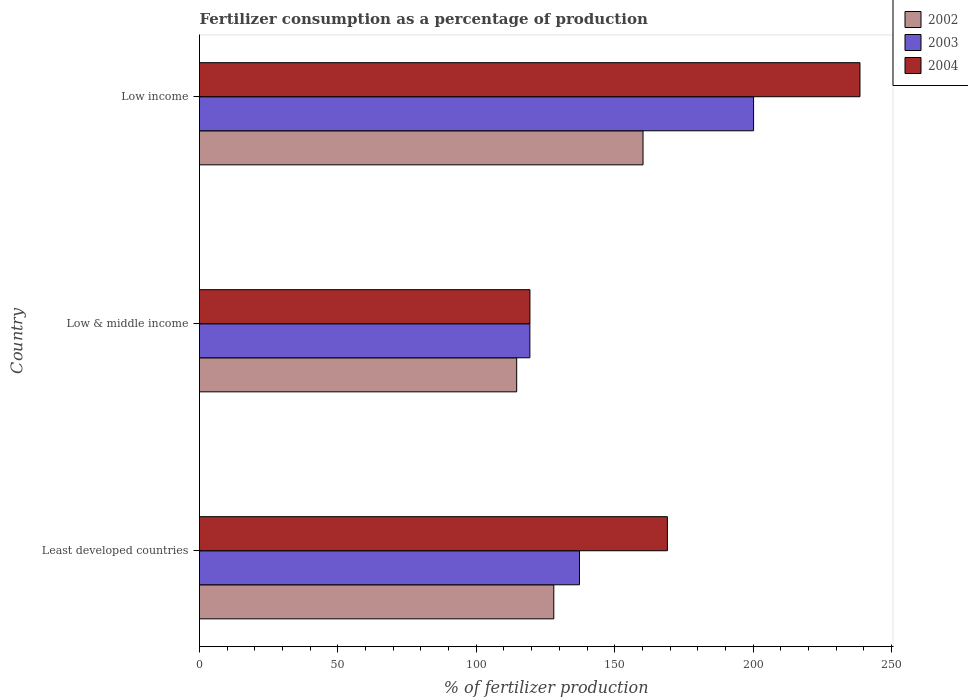How many different coloured bars are there?
Provide a short and direct response. 3. How many bars are there on the 3rd tick from the bottom?
Provide a succinct answer. 3. What is the label of the 1st group of bars from the top?
Your answer should be very brief. Low income. In how many cases, is the number of bars for a given country not equal to the number of legend labels?
Ensure brevity in your answer.  0. What is the percentage of fertilizers consumed in 2003 in Low & middle income?
Make the answer very short. 119.36. Across all countries, what is the maximum percentage of fertilizers consumed in 2004?
Offer a very short reply. 238.61. Across all countries, what is the minimum percentage of fertilizers consumed in 2004?
Ensure brevity in your answer.  119.38. What is the total percentage of fertilizers consumed in 2002 in the graph?
Provide a succinct answer. 402.83. What is the difference between the percentage of fertilizers consumed in 2003 in Low & middle income and that in Low income?
Your answer should be compact. -80.82. What is the difference between the percentage of fertilizers consumed in 2002 in Low income and the percentage of fertilizers consumed in 2004 in Least developed countries?
Provide a succinct answer. -8.8. What is the average percentage of fertilizers consumed in 2004 per country?
Ensure brevity in your answer.  175.68. What is the difference between the percentage of fertilizers consumed in 2003 and percentage of fertilizers consumed in 2002 in Least developed countries?
Give a very brief answer. 9.28. In how many countries, is the percentage of fertilizers consumed in 2004 greater than 20 %?
Make the answer very short. 3. What is the ratio of the percentage of fertilizers consumed in 2003 in Least developed countries to that in Low & middle income?
Keep it short and to the point. 1.15. Is the percentage of fertilizers consumed in 2004 in Least developed countries less than that in Low & middle income?
Give a very brief answer. No. What is the difference between the highest and the second highest percentage of fertilizers consumed in 2002?
Make the answer very short. 32.24. What is the difference between the highest and the lowest percentage of fertilizers consumed in 2003?
Give a very brief answer. 80.82. In how many countries, is the percentage of fertilizers consumed in 2004 greater than the average percentage of fertilizers consumed in 2004 taken over all countries?
Offer a very short reply. 1. What does the 3rd bar from the top in Low income represents?
Your answer should be very brief. 2002. What does the 2nd bar from the bottom in Least developed countries represents?
Your response must be concise. 2003. Are all the bars in the graph horizontal?
Provide a short and direct response. Yes. What is the difference between two consecutive major ticks on the X-axis?
Make the answer very short. 50. Are the values on the major ticks of X-axis written in scientific E-notation?
Provide a succinct answer. No. Does the graph contain any zero values?
Provide a succinct answer. No. Does the graph contain grids?
Keep it short and to the point. No. What is the title of the graph?
Provide a short and direct response. Fertilizer consumption as a percentage of production. Does "2010" appear as one of the legend labels in the graph?
Offer a very short reply. No. What is the label or title of the X-axis?
Make the answer very short. % of fertilizer production. What is the label or title of the Y-axis?
Your answer should be compact. Country. What is the % of fertilizer production of 2002 in Least developed countries?
Your answer should be very brief. 128. What is the % of fertilizer production of 2003 in Least developed countries?
Provide a succinct answer. 137.28. What is the % of fertilizer production of 2004 in Least developed countries?
Keep it short and to the point. 169.04. What is the % of fertilizer production of 2002 in Low & middle income?
Offer a terse response. 114.59. What is the % of fertilizer production of 2003 in Low & middle income?
Your response must be concise. 119.36. What is the % of fertilizer production in 2004 in Low & middle income?
Keep it short and to the point. 119.38. What is the % of fertilizer production in 2002 in Low income?
Ensure brevity in your answer.  160.24. What is the % of fertilizer production of 2003 in Low income?
Your answer should be compact. 200.18. What is the % of fertilizer production of 2004 in Low income?
Your answer should be very brief. 238.61. Across all countries, what is the maximum % of fertilizer production of 2002?
Your answer should be very brief. 160.24. Across all countries, what is the maximum % of fertilizer production in 2003?
Make the answer very short. 200.18. Across all countries, what is the maximum % of fertilizer production in 2004?
Give a very brief answer. 238.61. Across all countries, what is the minimum % of fertilizer production in 2002?
Offer a terse response. 114.59. Across all countries, what is the minimum % of fertilizer production in 2003?
Provide a short and direct response. 119.36. Across all countries, what is the minimum % of fertilizer production of 2004?
Provide a succinct answer. 119.38. What is the total % of fertilizer production in 2002 in the graph?
Keep it short and to the point. 402.83. What is the total % of fertilizer production of 2003 in the graph?
Ensure brevity in your answer.  456.81. What is the total % of fertilizer production in 2004 in the graph?
Your answer should be very brief. 527.03. What is the difference between the % of fertilizer production of 2002 in Least developed countries and that in Low & middle income?
Give a very brief answer. 13.4. What is the difference between the % of fertilizer production in 2003 in Least developed countries and that in Low & middle income?
Offer a terse response. 17.92. What is the difference between the % of fertilizer production in 2004 in Least developed countries and that in Low & middle income?
Your answer should be very brief. 49.66. What is the difference between the % of fertilizer production of 2002 in Least developed countries and that in Low income?
Your response must be concise. -32.24. What is the difference between the % of fertilizer production of 2003 in Least developed countries and that in Low income?
Keep it short and to the point. -62.9. What is the difference between the % of fertilizer production of 2004 in Least developed countries and that in Low income?
Provide a short and direct response. -69.57. What is the difference between the % of fertilizer production in 2002 in Low & middle income and that in Low income?
Offer a very short reply. -45.65. What is the difference between the % of fertilizer production in 2003 in Low & middle income and that in Low income?
Your answer should be compact. -80.82. What is the difference between the % of fertilizer production of 2004 in Low & middle income and that in Low income?
Keep it short and to the point. -119.23. What is the difference between the % of fertilizer production of 2002 in Least developed countries and the % of fertilizer production of 2003 in Low & middle income?
Offer a very short reply. 8.64. What is the difference between the % of fertilizer production of 2002 in Least developed countries and the % of fertilizer production of 2004 in Low & middle income?
Offer a very short reply. 8.62. What is the difference between the % of fertilizer production in 2003 in Least developed countries and the % of fertilizer production in 2004 in Low & middle income?
Ensure brevity in your answer.  17.9. What is the difference between the % of fertilizer production of 2002 in Least developed countries and the % of fertilizer production of 2003 in Low income?
Your answer should be compact. -72.18. What is the difference between the % of fertilizer production in 2002 in Least developed countries and the % of fertilizer production in 2004 in Low income?
Offer a terse response. -110.61. What is the difference between the % of fertilizer production of 2003 in Least developed countries and the % of fertilizer production of 2004 in Low income?
Provide a succinct answer. -101.33. What is the difference between the % of fertilizer production of 2002 in Low & middle income and the % of fertilizer production of 2003 in Low income?
Provide a short and direct response. -85.58. What is the difference between the % of fertilizer production of 2002 in Low & middle income and the % of fertilizer production of 2004 in Low income?
Provide a short and direct response. -124.02. What is the difference between the % of fertilizer production in 2003 in Low & middle income and the % of fertilizer production in 2004 in Low income?
Make the answer very short. -119.26. What is the average % of fertilizer production in 2002 per country?
Make the answer very short. 134.28. What is the average % of fertilizer production of 2003 per country?
Give a very brief answer. 152.27. What is the average % of fertilizer production in 2004 per country?
Give a very brief answer. 175.68. What is the difference between the % of fertilizer production in 2002 and % of fertilizer production in 2003 in Least developed countries?
Keep it short and to the point. -9.28. What is the difference between the % of fertilizer production of 2002 and % of fertilizer production of 2004 in Least developed countries?
Give a very brief answer. -41.04. What is the difference between the % of fertilizer production in 2003 and % of fertilizer production in 2004 in Least developed countries?
Your answer should be very brief. -31.76. What is the difference between the % of fertilizer production in 2002 and % of fertilizer production in 2003 in Low & middle income?
Your response must be concise. -4.76. What is the difference between the % of fertilizer production in 2002 and % of fertilizer production in 2004 in Low & middle income?
Your answer should be very brief. -4.79. What is the difference between the % of fertilizer production of 2003 and % of fertilizer production of 2004 in Low & middle income?
Offer a terse response. -0.02. What is the difference between the % of fertilizer production in 2002 and % of fertilizer production in 2003 in Low income?
Your answer should be compact. -39.94. What is the difference between the % of fertilizer production of 2002 and % of fertilizer production of 2004 in Low income?
Your response must be concise. -78.37. What is the difference between the % of fertilizer production in 2003 and % of fertilizer production in 2004 in Low income?
Your answer should be very brief. -38.43. What is the ratio of the % of fertilizer production of 2002 in Least developed countries to that in Low & middle income?
Give a very brief answer. 1.12. What is the ratio of the % of fertilizer production of 2003 in Least developed countries to that in Low & middle income?
Offer a very short reply. 1.15. What is the ratio of the % of fertilizer production of 2004 in Least developed countries to that in Low & middle income?
Offer a very short reply. 1.42. What is the ratio of the % of fertilizer production of 2002 in Least developed countries to that in Low income?
Provide a short and direct response. 0.8. What is the ratio of the % of fertilizer production in 2003 in Least developed countries to that in Low income?
Your response must be concise. 0.69. What is the ratio of the % of fertilizer production in 2004 in Least developed countries to that in Low income?
Offer a terse response. 0.71. What is the ratio of the % of fertilizer production of 2002 in Low & middle income to that in Low income?
Your answer should be compact. 0.72. What is the ratio of the % of fertilizer production in 2003 in Low & middle income to that in Low income?
Your response must be concise. 0.6. What is the ratio of the % of fertilizer production of 2004 in Low & middle income to that in Low income?
Give a very brief answer. 0.5. What is the difference between the highest and the second highest % of fertilizer production of 2002?
Give a very brief answer. 32.24. What is the difference between the highest and the second highest % of fertilizer production of 2003?
Your answer should be compact. 62.9. What is the difference between the highest and the second highest % of fertilizer production in 2004?
Ensure brevity in your answer.  69.57. What is the difference between the highest and the lowest % of fertilizer production of 2002?
Your answer should be compact. 45.65. What is the difference between the highest and the lowest % of fertilizer production of 2003?
Make the answer very short. 80.82. What is the difference between the highest and the lowest % of fertilizer production in 2004?
Keep it short and to the point. 119.23. 